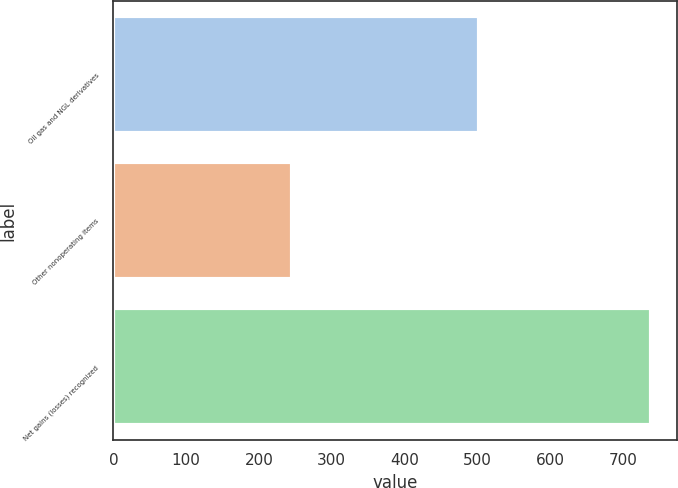Convert chart to OTSL. <chart><loc_0><loc_0><loc_500><loc_500><bar_chart><fcel>Oil gas and NGL derivatives<fcel>Other nonoperating items<fcel>Net gains (losses) recognized<nl><fcel>503<fcel>246<fcel>738<nl></chart> 